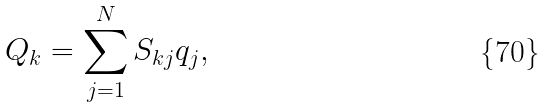<formula> <loc_0><loc_0><loc_500><loc_500>Q _ { k } = \sum _ { j = 1 } ^ { N } S _ { k j } q _ { j } ,</formula> 